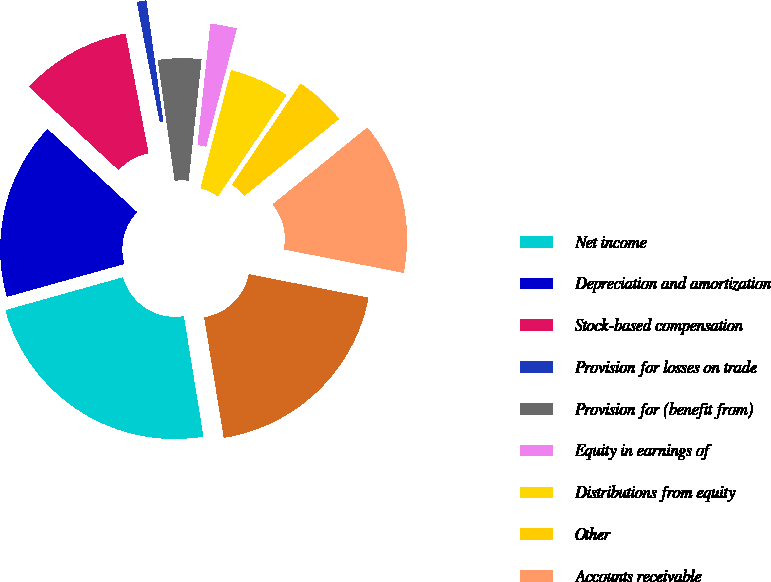Convert chart to OTSL. <chart><loc_0><loc_0><loc_500><loc_500><pie_chart><fcel>Net income<fcel>Depreciation and amortization<fcel>Stock-based compensation<fcel>Provision for losses on trade<fcel>Provision for (benefit from)<fcel>Equity in earnings of<fcel>Distributions from equity<fcel>Other<fcel>Accounts receivable<fcel>Inventories<nl><fcel>23.22%<fcel>16.26%<fcel>10.08%<fcel>0.8%<fcel>3.89%<fcel>2.35%<fcel>5.44%<fcel>4.67%<fcel>13.94%<fcel>19.35%<nl></chart> 